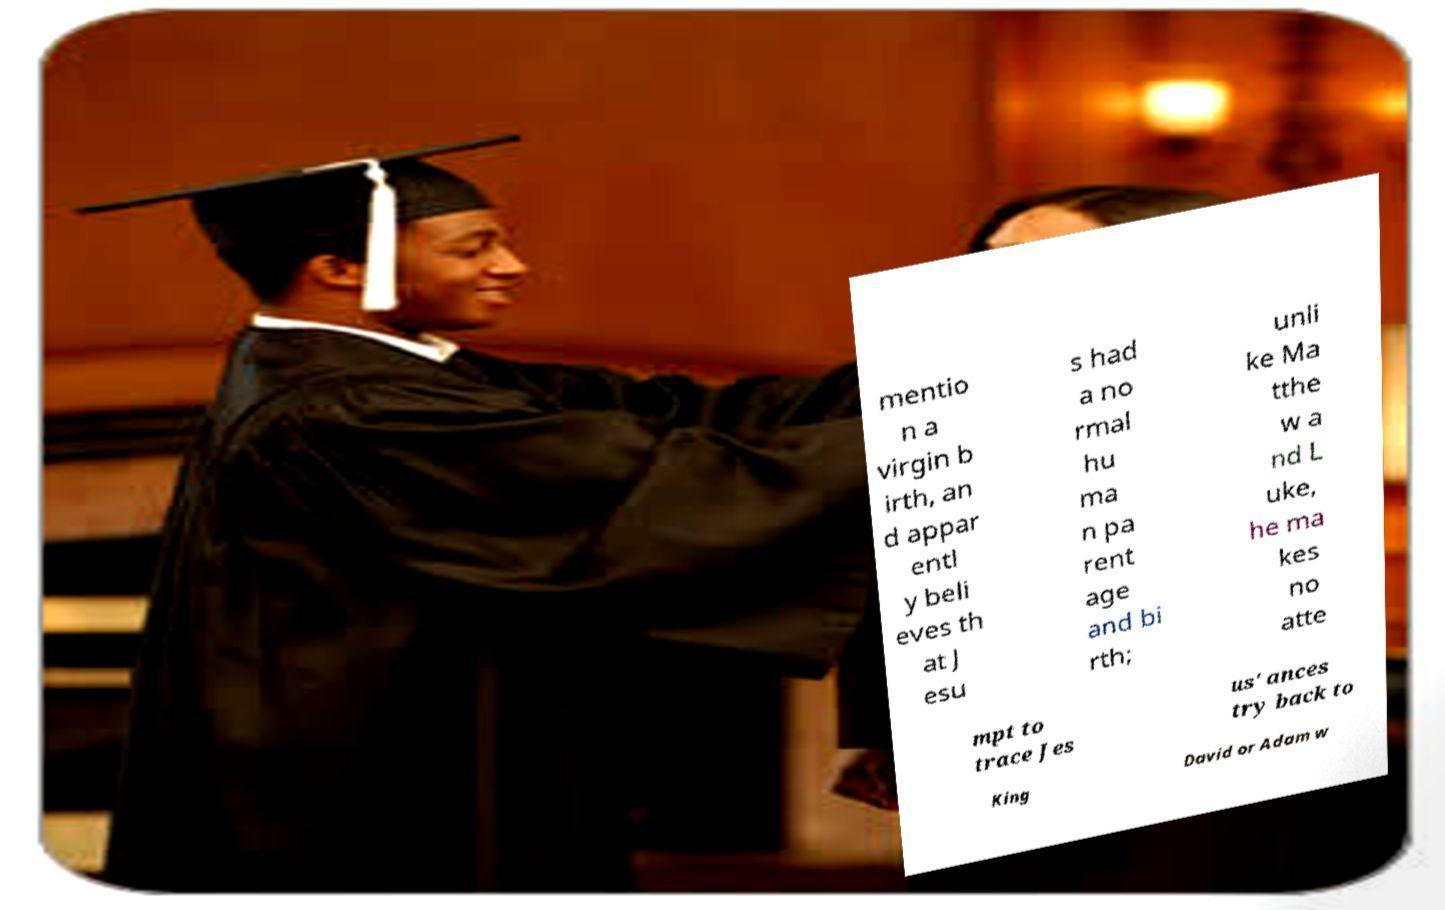Could you assist in decoding the text presented in this image and type it out clearly? mentio n a virgin b irth, an d appar entl y beli eves th at J esu s had a no rmal hu ma n pa rent age and bi rth; unli ke Ma tthe w a nd L uke, he ma kes no atte mpt to trace Jes us' ances try back to King David or Adam w 